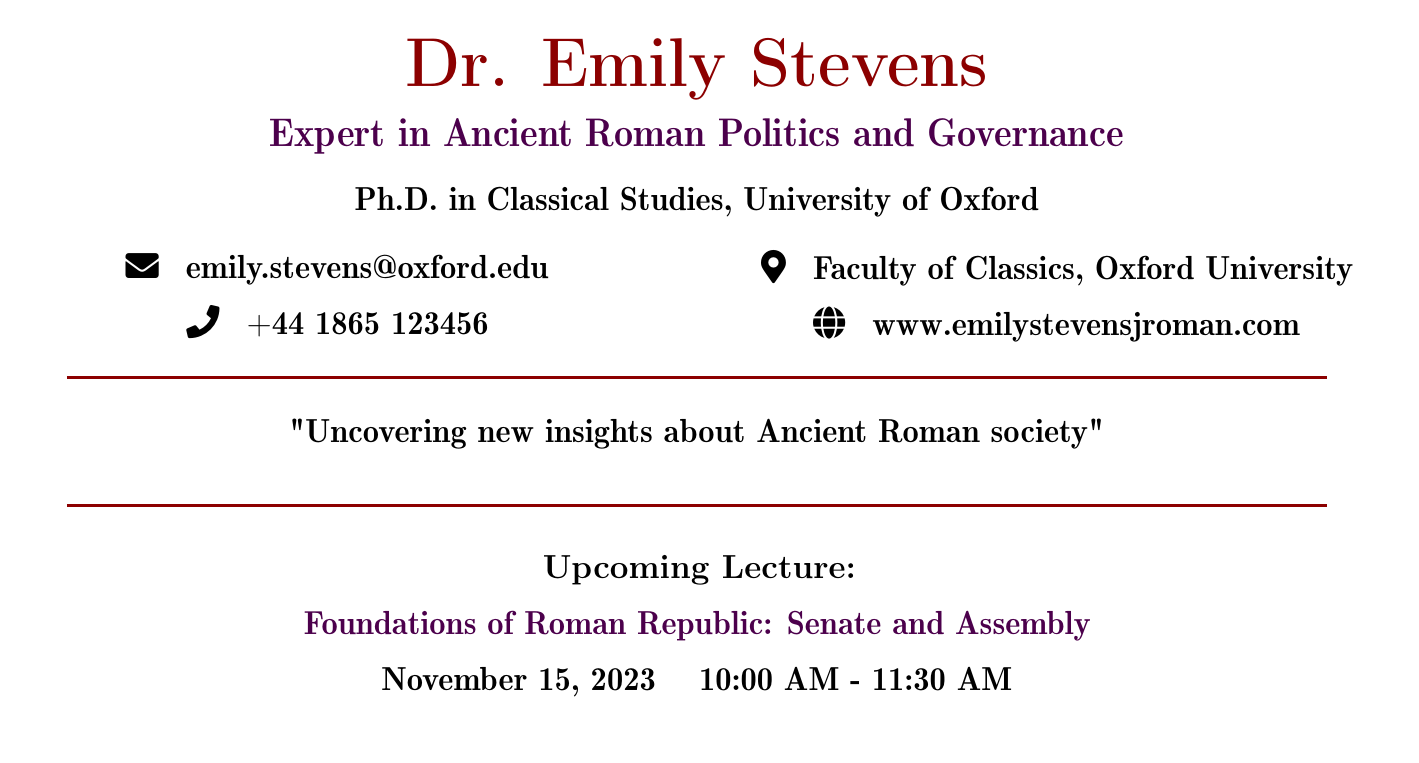What is the speaker's name? The speaker's name is listed at the top of the document.
Answer: Dr. Emily Stevens What is the topic of the lecture? The topic of the lecture is found towards the bottom of the document, labeled under upcoming lecture.
Answer: Foundations of Roman Republic: Senate and Assembly What is the date of the lecture? The date is mentioned in the details of the upcoming lecture section.
Answer: November 15, 2023 What time does the lecture start? The starting time of the lecture is clearly indicated in the schedule.
Answer: 10:00 AM What is the speaker's email address? The email address is provided in the contact information section of the document.
Answer: emily.stevens@oxford.edu Where does Dr. Emily Stevens work? The workplace is mentioned under the contact information section.
Answer: Faculty of Classics, Oxford University What is Dr. Emily Stevens' highest degree? The highest degree obtained by the speaker is mentioned in the document's introduction.
Answer: Ph.D. in Classical Studies What is the speaker's area of expertise? The area of expertise is specified right below the speaker's name.
Answer: Ancient Roman Politics and Governance What is the speaker's website? The website is included in the contact information section of the document.
Answer: www.emilystevensjroman.com What is the purpose of the document? The purpose is expressed in a quote towards the center of the document.
Answer: Uncovering new insights about Ancient Roman society 